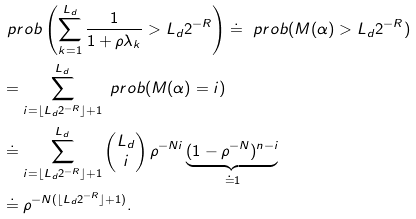Convert formula to latex. <formula><loc_0><loc_0><loc_500><loc_500>& \ p r o b \left ( \sum _ { k = 1 } ^ { L _ { d } } \frac { 1 } { 1 + \rho \lambda _ { k } } > L _ { d } 2 ^ { - R } \right ) \doteq \ p r o b ( M ( \alpha ) > L _ { d } 2 ^ { - R } ) \\ & = \sum _ { i = \lfloor L _ { d } 2 ^ { - R } \rfloor + 1 } ^ { L _ { d } } \ p r o b ( M ( \alpha ) = i ) \\ & \doteq \sum _ { i = \lfloor L _ { d } 2 ^ { - R } \rfloor + 1 } ^ { L _ { d } } \begin{pmatrix} { L _ { d } } \\ { i } \end{pmatrix} \rho ^ { - N i } \underbrace { ( 1 - \rho ^ { - N } ) ^ { n - i } } _ { \doteq 1 } \\ & \doteq \rho ^ { - N { ( \lfloor L _ { d } 2 ^ { - R } \rfloor + 1 ) } } .</formula> 